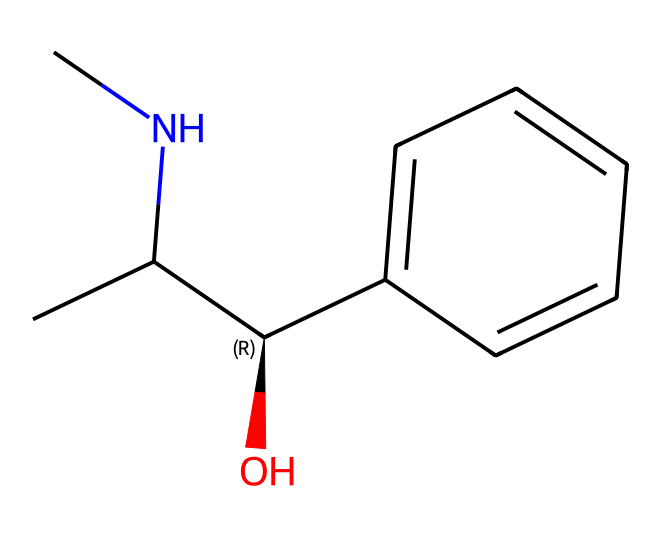What is the main functional group present in ephedrine? The structure shows an alcohol group (–OH) attached to a carbon atom, which is a key functional group in ephedrine.
Answer: alcohol How many carbon atoms are in the molecular structure of ephedrine? By counting the carbon symbols in the SMILES representation, there are 10 carbon atoms present.
Answer: 10 What is the configuration of the chiral center in ephedrine? The chiral center in ephedrine is indicated by the "@". The configuration is specified as "C@H", meaning it is in an S configuration.
Answer: S Is ephedrine classified as a stimulant? The chemical structure of ephedrine suggests it acts as a stimulant due to the presence of the amine group, which is common in stimulants.
Answer: yes What type of alkaloid does ephedrine belong to? Ephedrine is classified specifically as a phenethylamine alkaloid due to its structure, which includes a phenyl ring and an ethyl amine chain.
Answer: phenethylamine Does ephedrine contain any nitrogen atoms? The SMILES representation clearly includes "N", indicating the presence of one nitrogen atom in the structure.
Answer: yes 